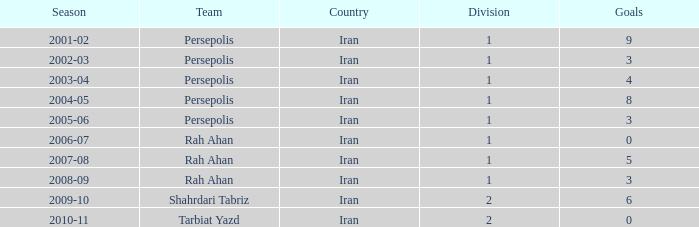In the 2005-06 season, what is the combined number of goals for divisions less than 1? None. 